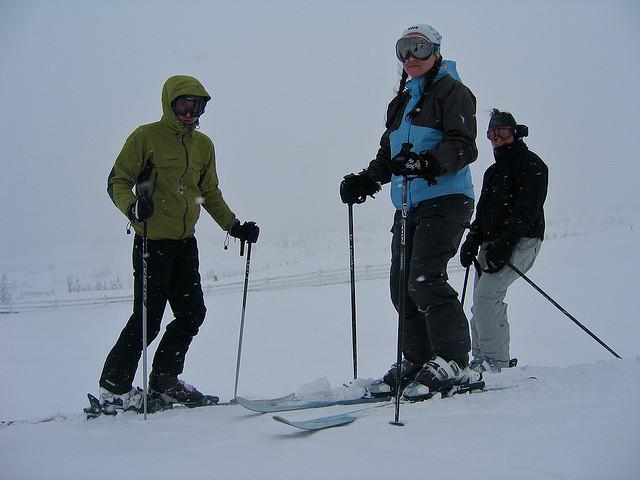What are in the skiers hands?
Keep it brief. Poles. What activity is happening in this photo?
Give a very brief answer. Skiing. How many people are in the picture?
Give a very brief answer. 3. How many ski poles are there?
Concise answer only. 6. Is there wind blowing?
Concise answer only. Yes. 